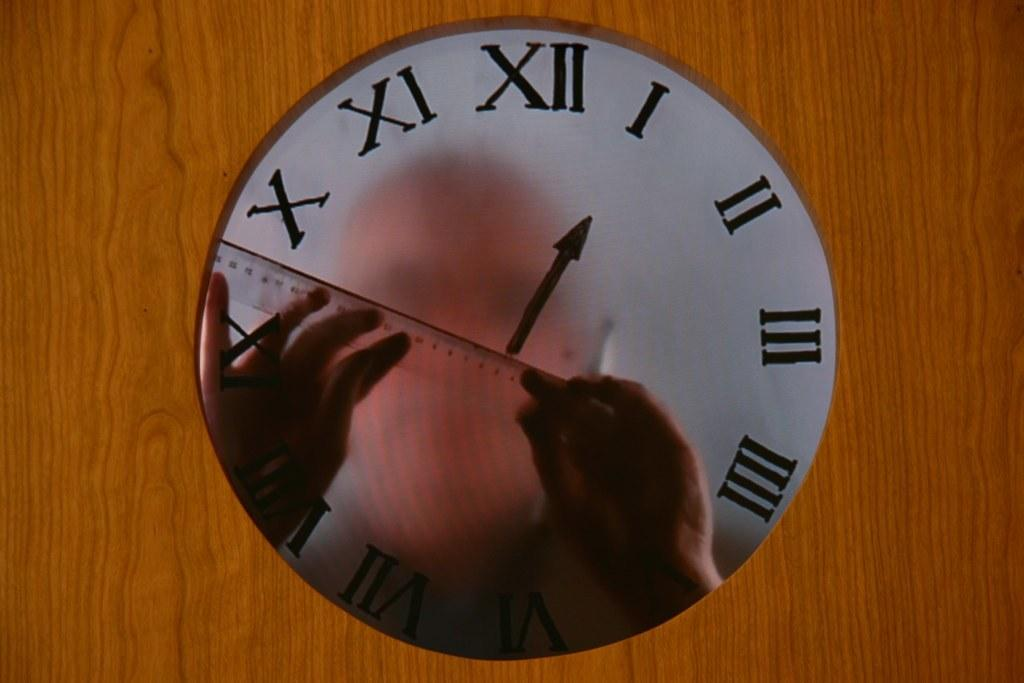<image>
Render a clear and concise summary of the photo. A clock with a mirrored face that says one o clock on it. 